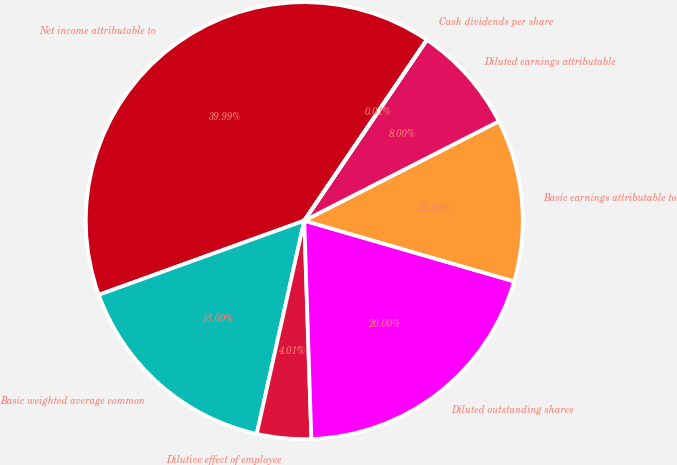Convert chart. <chart><loc_0><loc_0><loc_500><loc_500><pie_chart><fcel>Net income attributable to<fcel>Basicweighted average common<fcel>Dilutive effect of employee<fcel>Diluted outstanding shares<fcel>Basic earnings attributable to<fcel>Diluted earnings attributable<fcel>Cash dividends per share<nl><fcel>39.99%<fcel>16.0%<fcel>4.01%<fcel>20.0%<fcel>12.0%<fcel>8.0%<fcel>0.01%<nl></chart> 